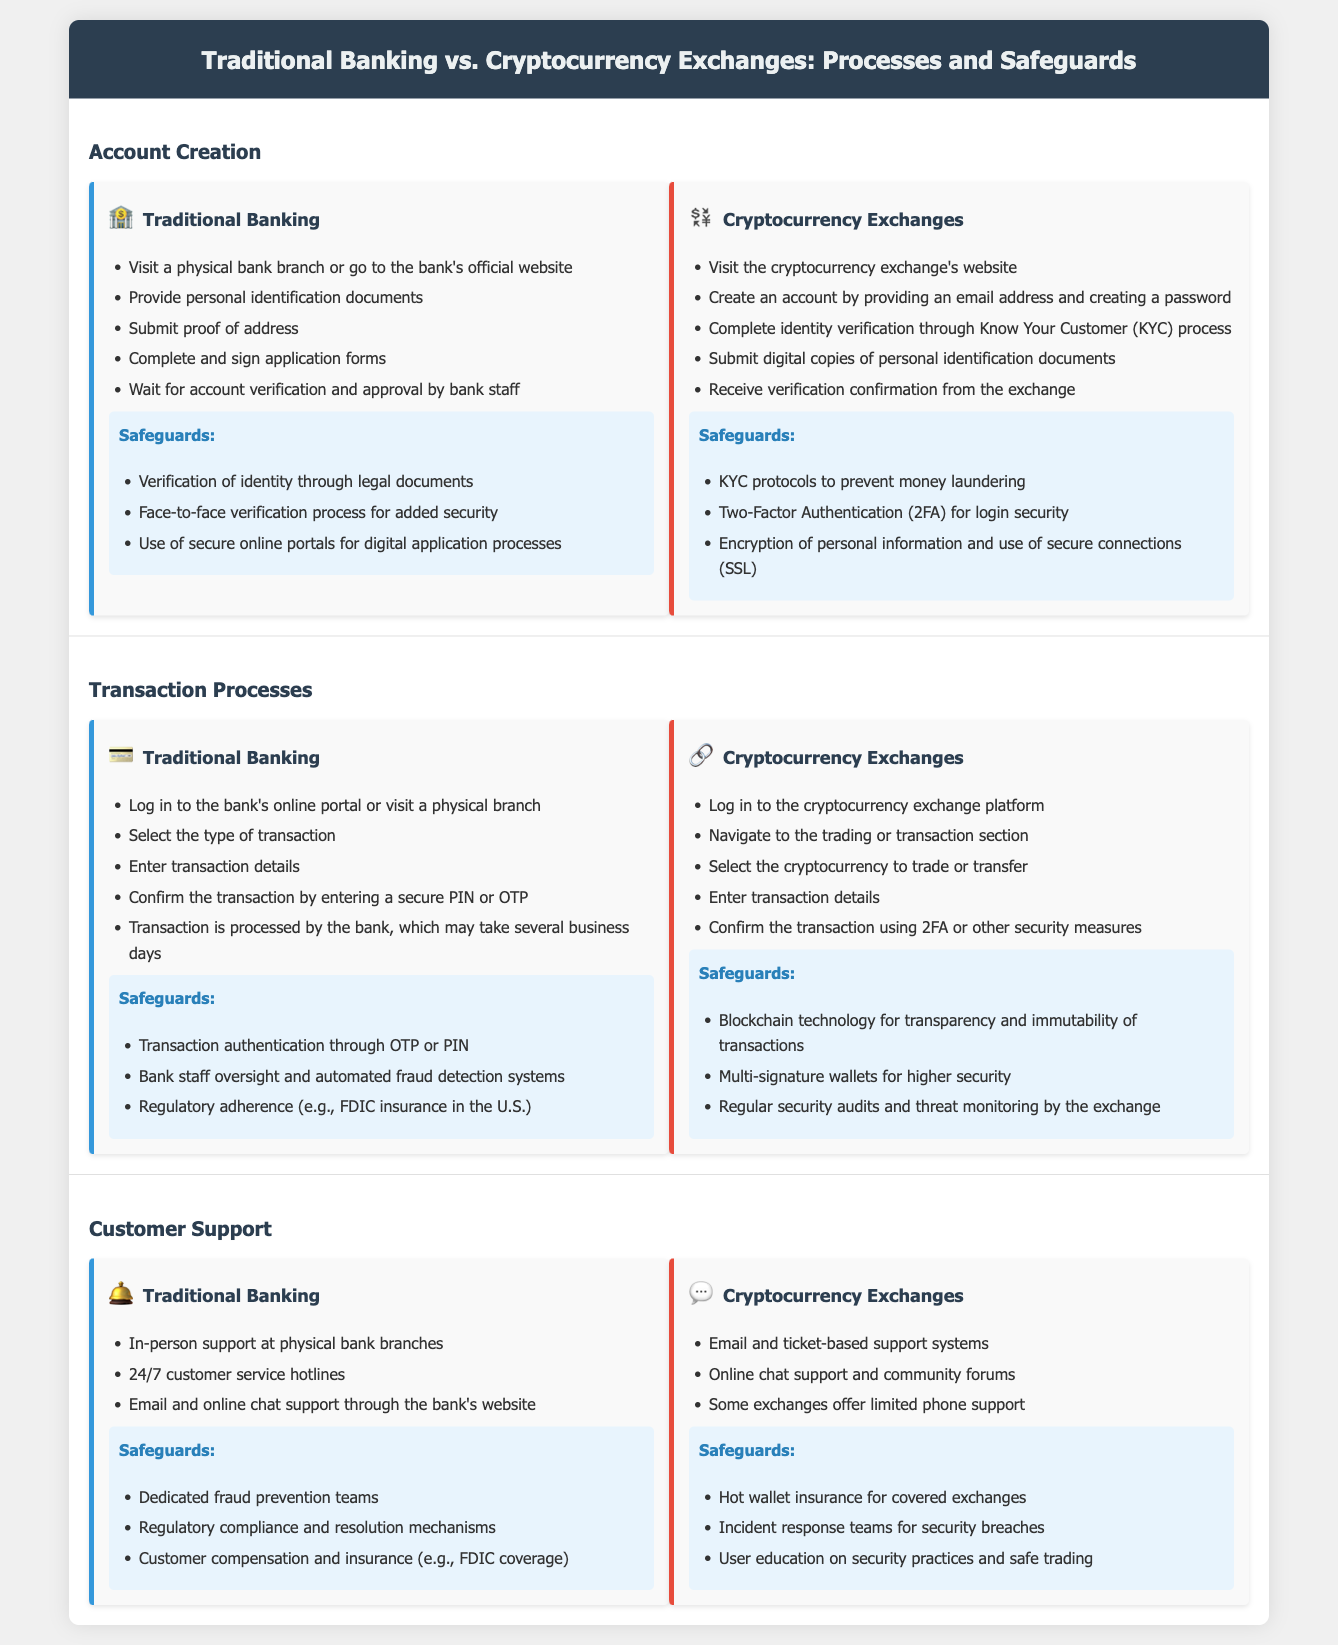What documents are needed for Traditional Banking account creation? The document lists personal identification documents and proof of address as requirements for account creation in Traditional Banking.
Answer: personal identification documents, proof of address What is the identity verification process for Cryptocurrency Exchanges? The Cryptocurrency Exchanges require a Know Your Customer (KYC) process for identity verification, which includes submitting digital copies of personal identification documents.
Answer: KYC process How long can a transaction in Traditional Banking take? The document states that transactions processed by banks may take several business days to complete.
Answer: several business days What safeguard is unique to Cryptocurrency Exchanges for transaction processes? Multi-signature wallets are mentioned as a safeguard for higher security specifically in Cryptocurrency Exchanges.
Answer: Multi-signature wallets What type of support does Traditional Banking provide for customer care? The document indicates that Traditional Banking provides in-person support at physical bank branches.
Answer: in-person support Which safeguard involves user education in Cryptocurrency Exchanges? The document specifies that user education on security practices and safe trading is a safeguard within Cryptocurrency Exchanges.
Answer: user education on security practices How many types of safeguards are listed for both Traditional Banking and Cryptocurrency Exchanges? The document specifies three safeguards for Traditional Banking and three for Cryptocurrency Exchanges, thus totaling six.
Answer: six What is the process of submitting an account application in Traditional Banking? The application process includes completing and signing application forms and waiting for account verification and approval.
Answer: completing and signing application forms, waiting for verification What type of authentication is used in Cryptocurrency Exchanges during login? The document highlights Two-Factor Authentication (2FA) as a security measure for login in Cryptocurrency Exchanges.
Answer: Two-Factor Authentication (2FA) 